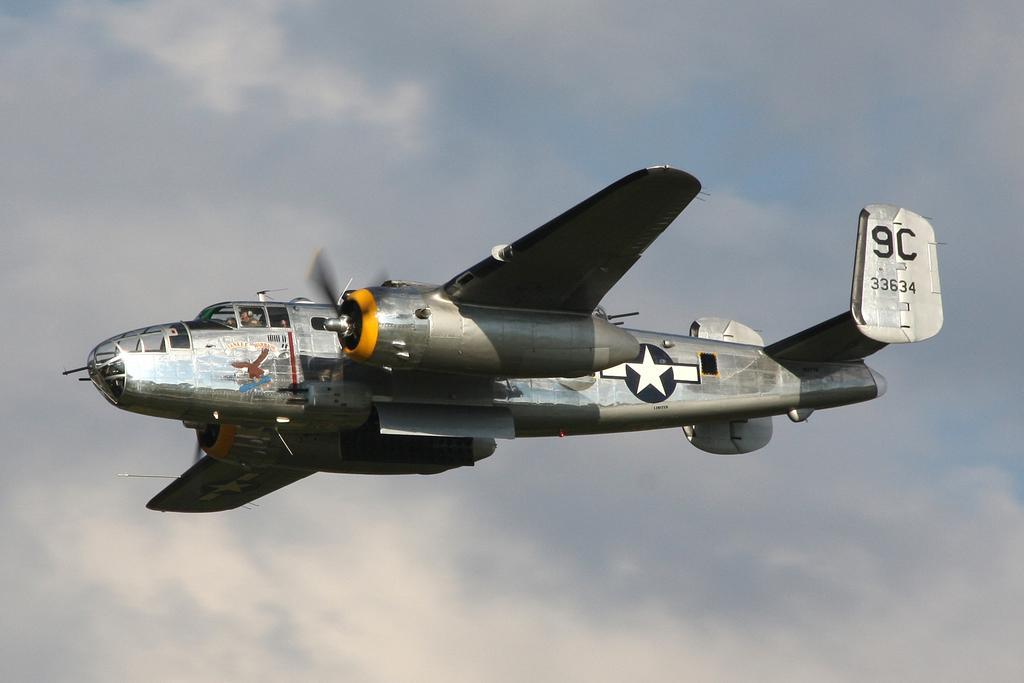In one or two sentences, can you explain what this image depicts? In the middle of the picture we can see a flying jet, flying in the sky. There is even a cloudy pale blue sky. 